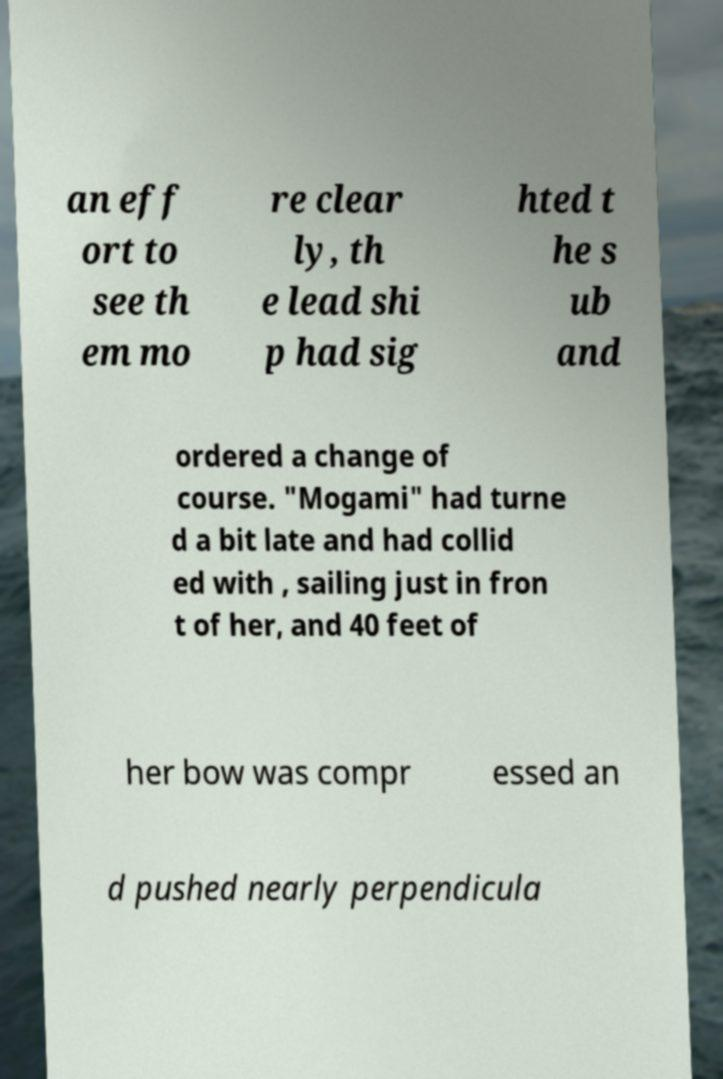Could you assist in decoding the text presented in this image and type it out clearly? an eff ort to see th em mo re clear ly, th e lead shi p had sig hted t he s ub and ordered a change of course. "Mogami" had turne d a bit late and had collid ed with , sailing just in fron t of her, and 40 feet of her bow was compr essed an d pushed nearly perpendicula 